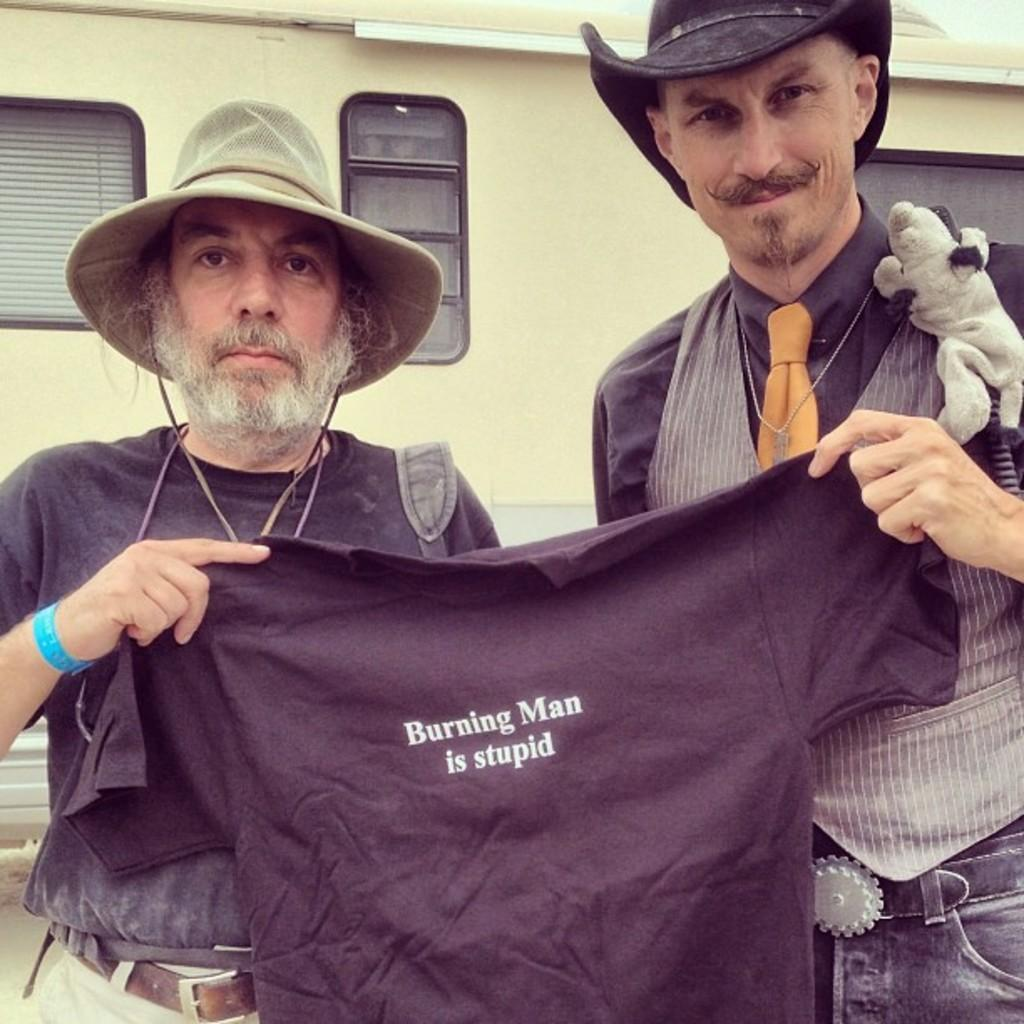How many people are in the image? There are two men in the image. What are the men doing in the image? The men are standing and holding a t-shirt. What are the men wearing on their heads? The men are wearing caps. What can be seen in the background of the image? There is a window visible in the background of the image. What is the condition of the picture frame in the image? There is no picture frame present in the image. What type of part can be seen in the picture? The image does not depict a specific part; it shows two men standing and holding a t-shirt. 